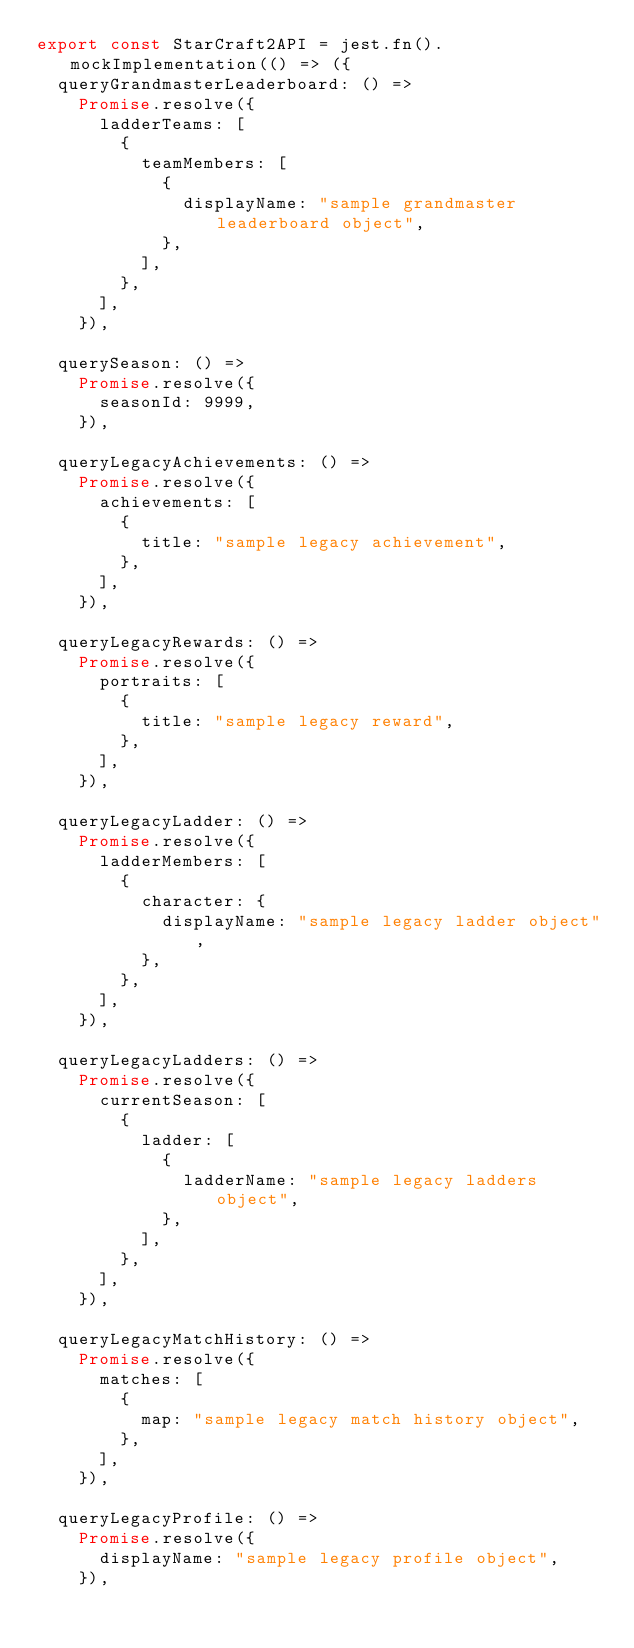<code> <loc_0><loc_0><loc_500><loc_500><_TypeScript_>export const StarCraft2API = jest.fn().mockImplementation(() => ({
  queryGrandmasterLeaderboard: () =>
    Promise.resolve({
      ladderTeams: [
        {
          teamMembers: [
            {
              displayName: "sample grandmaster leaderboard object",
            },
          ],
        },
      ],
    }),

  querySeason: () =>
    Promise.resolve({
      seasonId: 9999,
    }),

  queryLegacyAchievements: () =>
    Promise.resolve({
      achievements: [
        {
          title: "sample legacy achievement",
        },
      ],
    }),

  queryLegacyRewards: () =>
    Promise.resolve({
      portraits: [
        {
          title: "sample legacy reward",
        },
      ],
    }),

  queryLegacyLadder: () =>
    Promise.resolve({
      ladderMembers: [
        {
          character: {
            displayName: "sample legacy ladder object",
          },
        },
      ],
    }),

  queryLegacyLadders: () =>
    Promise.resolve({
      currentSeason: [
        {
          ladder: [
            {
              ladderName: "sample legacy ladders object",
            },
          ],
        },
      ],
    }),

  queryLegacyMatchHistory: () =>
    Promise.resolve({
      matches: [
        {
          map: "sample legacy match history object",
        },
      ],
    }),

  queryLegacyProfile: () =>
    Promise.resolve({
      displayName: "sample legacy profile object",
    }),
</code> 